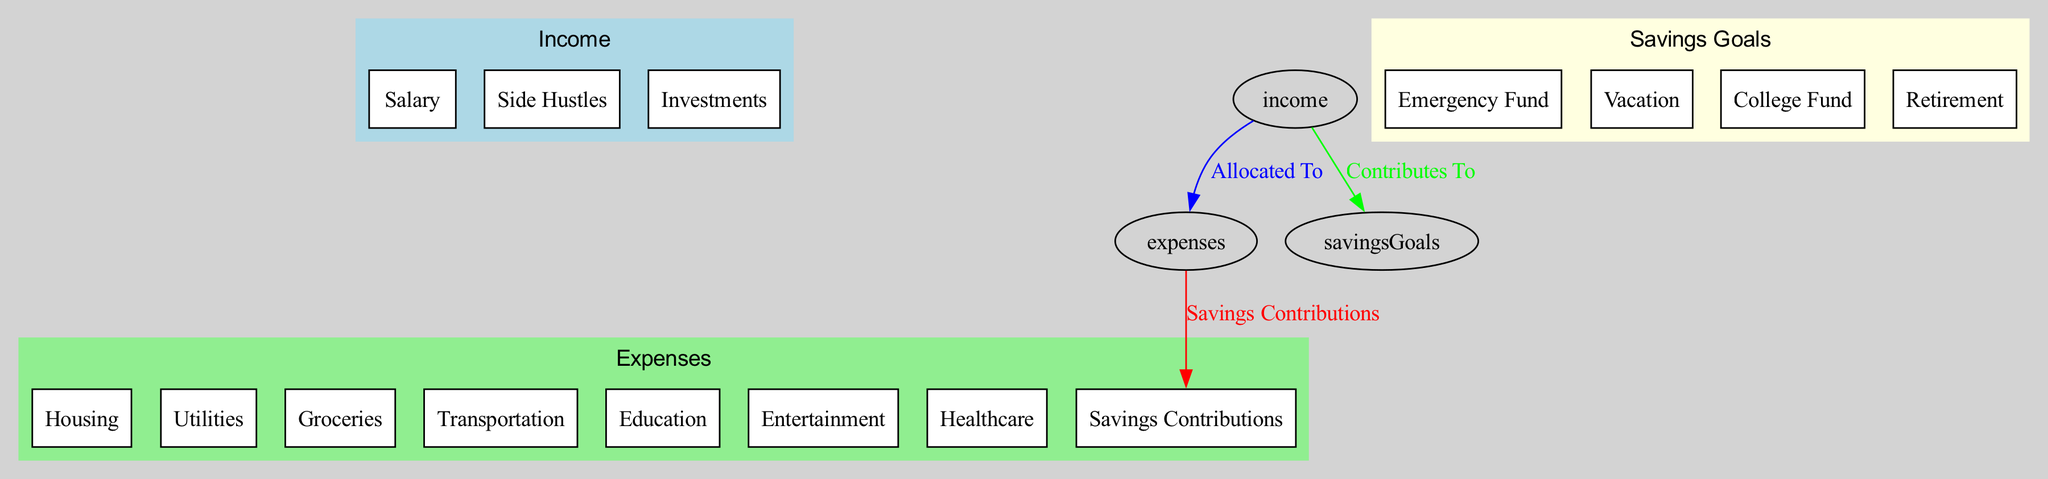What are the three main categories shown in the diagram? The diagram has three main categories, which are Income, Expenses, and Savings Goals. Each category is represented as a cluster in the diagram.
Answer: Income, Expenses, Savings Goals How many types of income are listed? The Income category includes three types: Salary, Side Hustles, and Investments. The diagram makes this clear through the specified elements under the Income cluster.
Answer: Three Which expense category directly contributes to savings? The Expenses category shows that Savings Contributions are an expense type. This indicates that part of the expenses is allocated towards savings, as represented by an edge from Expenses to Savings Contributions.
Answer: Savings Contributions What is the goal related to retirement? The Savings Goals section includes a specific goal labeled Retirement. This means that among the savings goals intended for the future, Retirement is explicitly mentioned.
Answer: Retirement How does income relate to expenses? Income is allocated to expenses as indicated by the edge labeled "Allocated To" connecting these two categories. This suggests that the income directly funds the various expense elements within the household budget.
Answer: Allocated To How many savings goals are represented? In the Savings Goals category, there are four specific savings goals: Emergency Fund, Vacation, College Fund, and Retirement. Thus, the total is counted directly from the elements under the Savings Goals.
Answer: Four What type of expense includes education costs? The Expenses category clearly identifies Education as a separate element, thereby indicating that this specific expense type covers costs related to education.
Answer: Education What connects expenses to savings contributions? The edge labeled "Savings Contributions" connects the Expenses category to the specific savings contributions. This signifies that a portion of the expenses goes towards savings.
Answer: Savings Contributions 